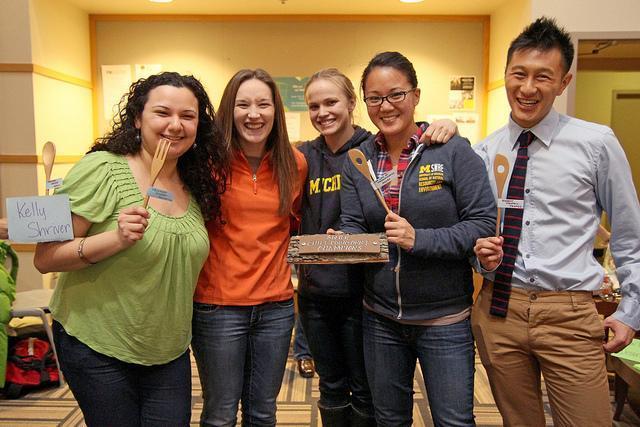How many men are in the picture?
Give a very brief answer. 1. How many people are smiling?
Give a very brief answer. 5. How many people are standing?
Give a very brief answer. 5. How many men are in the photo?
Give a very brief answer. 1. How many girls are present?
Give a very brief answer. 4. How many people are there?
Give a very brief answer. 5. 